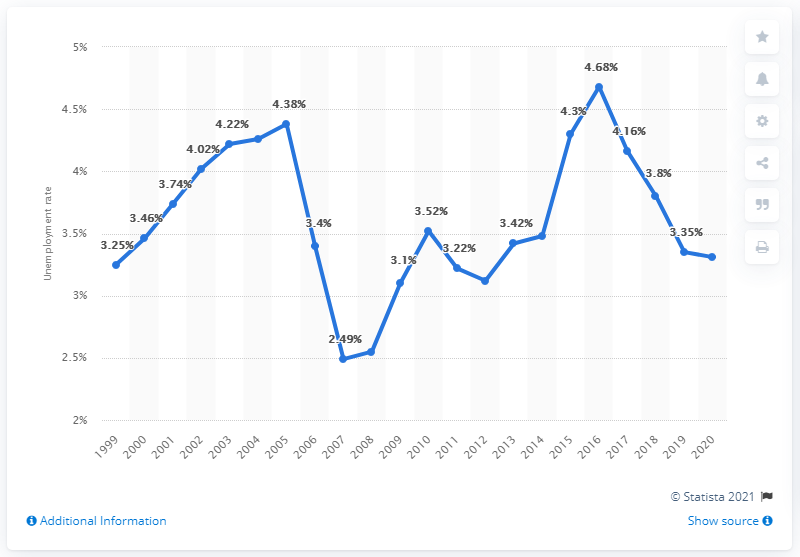Apart from the year 2020, which year had the highest unemployment rate? Excluding the year 2020, the graph shows that the highest unemployment rate was in 2016, where it reached 4.68%. This could be associated with various economic factors or market changes specific to that period. 